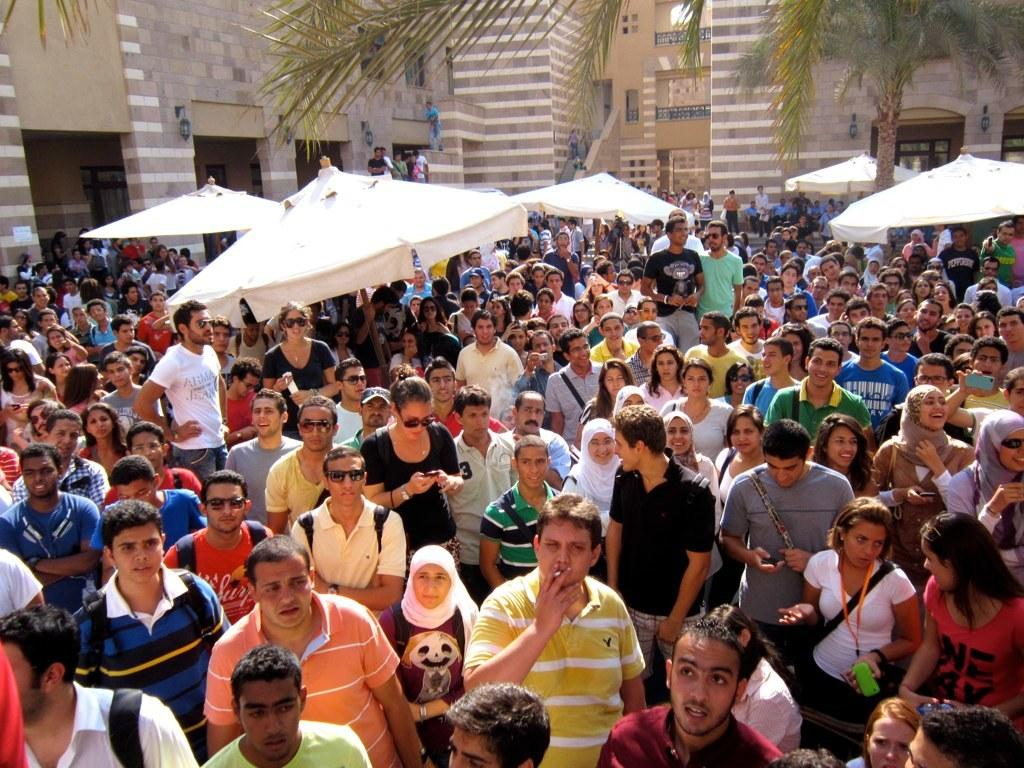How many people are in the image? There is a group of people in the image, but the exact number cannot be determined from the provided facts. What are the people in the image doing? Some people are standing, while others are walking. What type of structures can be seen in the image? There are white-colored tents, gray and cream-colored buildings, and green-colored trees in the image. What type of credit card is being used by the person in the image? There is no credit card visible in the image. How many blades are attached to the head of the person in the image? There is no person with blades attached to their head in the image. 